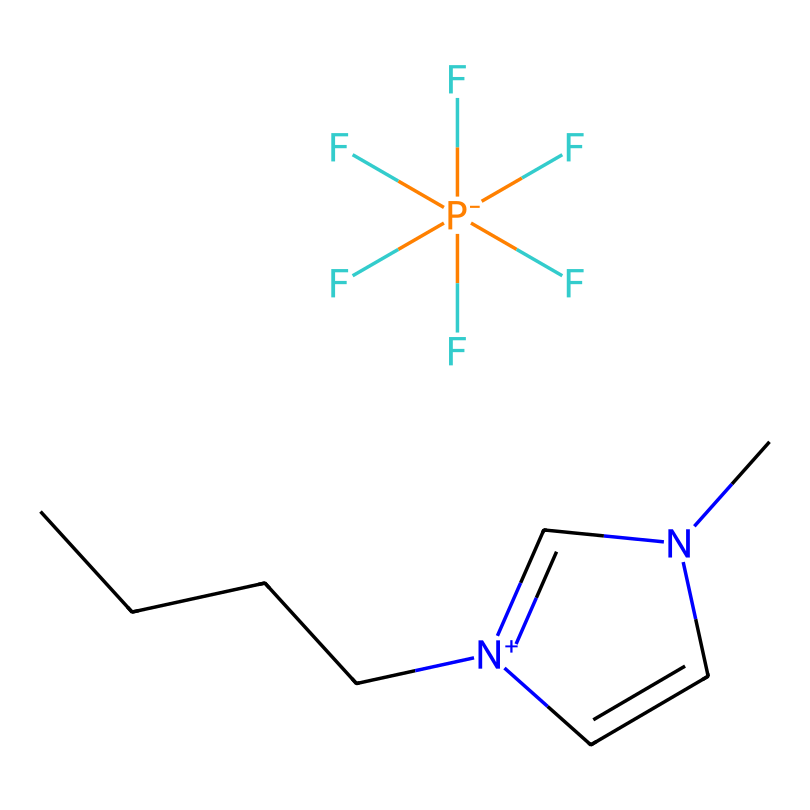What is the molecular formula of this ionic liquid? By analyzing the SMILES representation, the components can be identified: 1-butyl-3-methylimidazolium has four carbons as part of the butyl and one from the methyl, along with two nitrogen atoms, making the total C: 7, H: 13, N: 2. The hexafluorophosphate contributes P: 1 and F: 6. Therefore, we can combine these components to deduce the molecular formula: C7H13N2PF6.
Answer: C7H13N2PF6 How many carbon atoms are in the compound? In the SMILES representation, there are 7 carbon atoms visible when we break down the butyl (4) and methyl (1) groups along with the imidazole ring (2). Hence, counting reveals a total of 7 carbon atoms in the compound.
Answer: 7 What type of ionic liquid is represented here? This compound is characterized as a room-temperature ionic liquid due to its structure, which is typically stable and liquid at or near room temperature. The presence of an imidazolium cation reinforces its classification.
Answer: room-temperature ionic liquid How many nitrogen atoms are present in this chemical? From the SMILES representation, two nitrogen atoms can be clearly identified within the imidazole ring structure, thus confirming that the compound contains two nitrogen atoms overall.
Answer: 2 What is the charge of the cation in this ionic liquid? In the provided structure, the imidazolium part carries a positive charge as indicated by the [n+] notation in the SMILES representation. This indicates that the cation is positively charged.
Answer: positive How many fluorine atoms does the anion have? The hexafluorophosphate anion [P-](F)(F)(F)(F)(F)F clearly shows 6 fluorine atoms connected to the phosphorus atom as deduced from the notation in the SMILES representation. Count the number of 'F' which totals to six.
Answer: 6 What role does the imidazolium cation play in ionic liquids? In ionic liquids, the imidazolium cation often contributes to properties like low volatility and high thermal stability, and its desolvation characteristics enhance the ionic conductivity of the liquid. Therefore, it plays a functional role in achieving desirable ionic liquid properties.
Answer: properties enhancer 